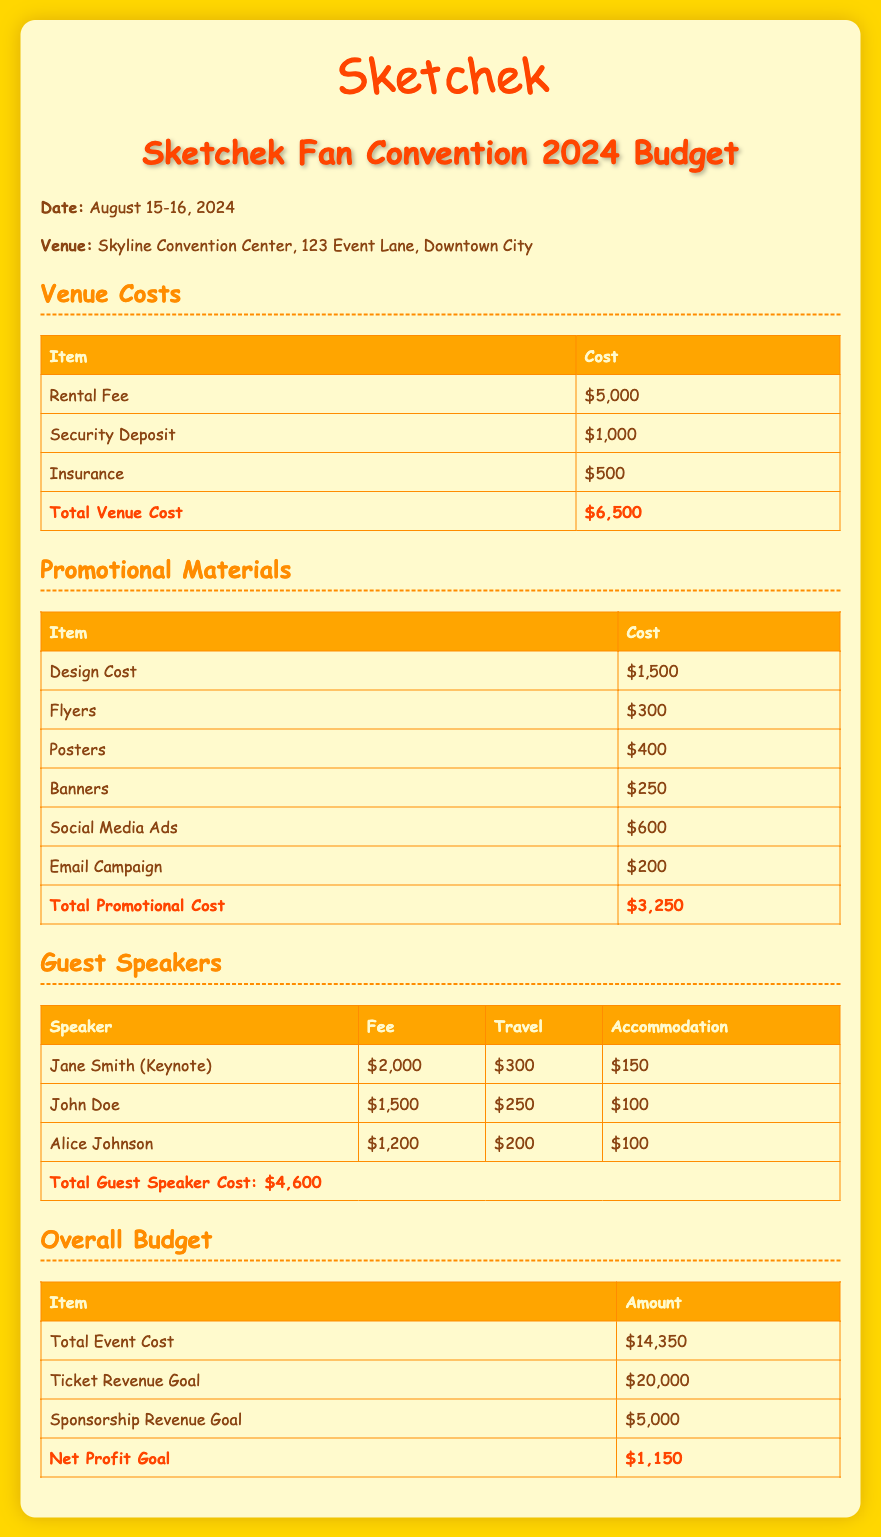What is the date of the Sketchek fan convention? The date is mentioned in the document and is August 15-16, 2024.
Answer: August 15-16, 2024 What is the total venue cost? The total venue cost is provided in the budget section for venue costs, which sums up the individual costs.
Answer: $6,500 How much is allocated for promotional materials? The total for promotional materials is listed at the end of the promotional materials section.
Answer: $3,250 What is the fee for the keynote speaker, Jane Smith? The document specifies the fee for Jane Smith in the guest speakers section.
Answer: $2,000 What is the total guest speaker cost? The total guest speaker cost is given at the bottom of the guest speakers section, summing all individual fees and costs.
Answer: $4,600 What is the total event cost? The total event cost is indicated in the overall budget section, combining all expenses.
Answer: $14,350 What is the ticket revenue goal? The ticket revenue goal is stated in the overall budget section as a specific amount.
Answer: $20,000 What is the net profit goal? The net profit goal is derived from the overall budget, calculated from revenue and expenses, and is specified in the document.
Answer: $1,150 How much is spent on social media ads? The document lists the cost allocated for social media ads in the promotional materials section.
Answer: $600 